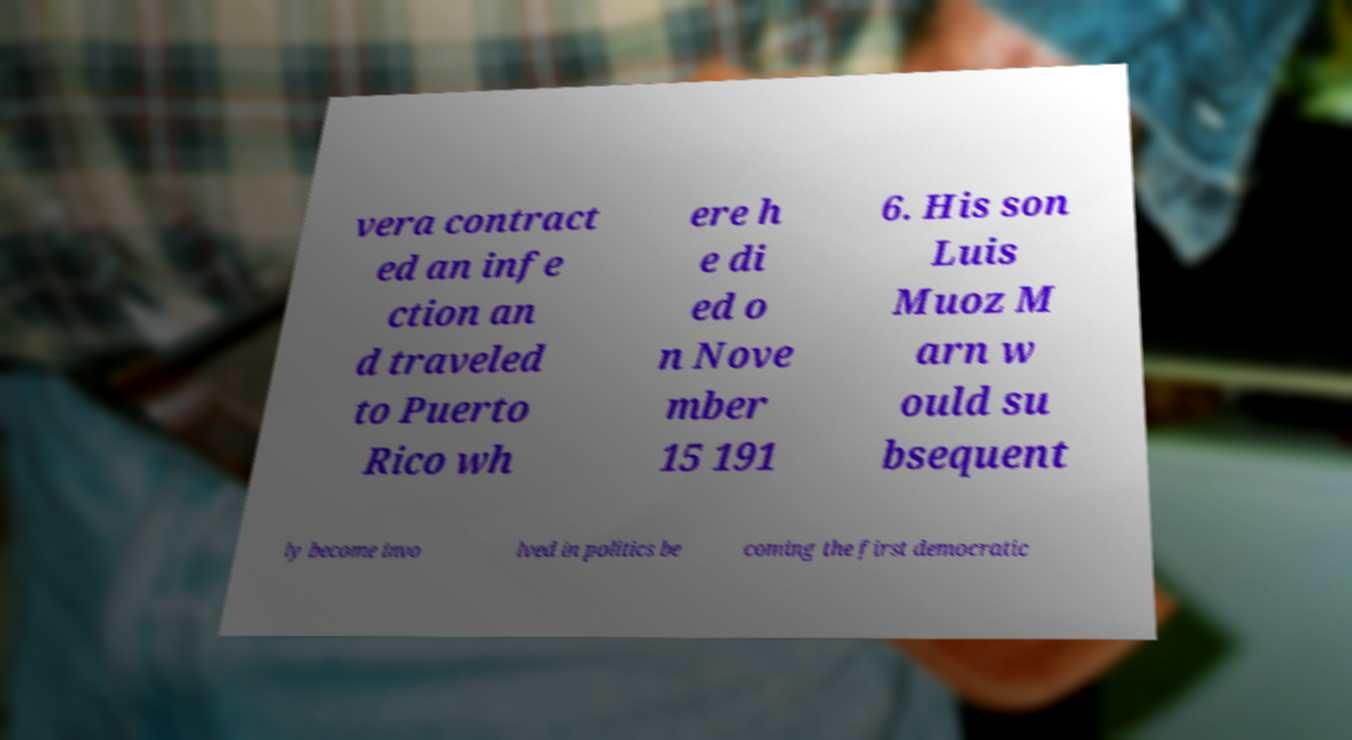Please read and relay the text visible in this image. What does it say? vera contract ed an infe ction an d traveled to Puerto Rico wh ere h e di ed o n Nove mber 15 191 6. His son Luis Muoz M arn w ould su bsequent ly become invo lved in politics be coming the first democratic 